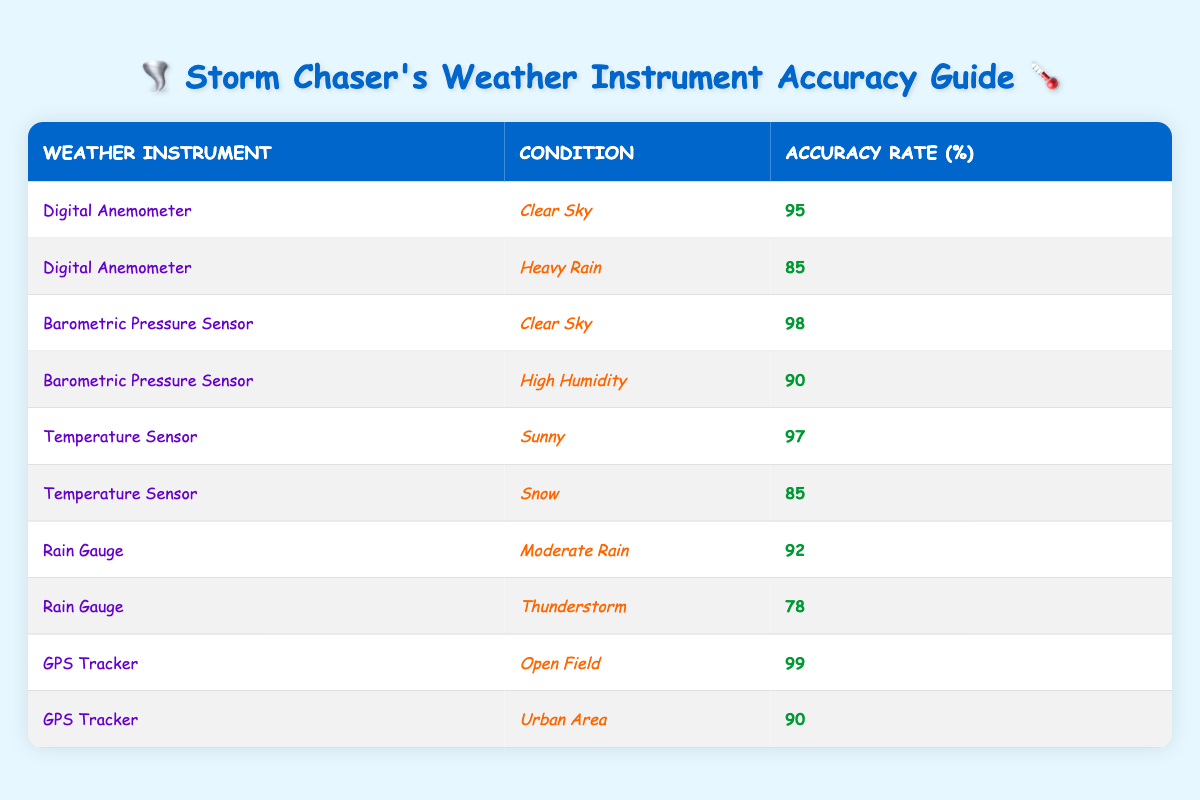What is the accuracy rate of the Digital Anemometer in Clear Sky conditions? The table lists the accuracy rate for the Digital Anemometer under Clear Sky conditions as 95 percent.
Answer: 95 Which weather instrument has the highest accuracy rate in any condition? Upon examining the data, the GPS Tracker has the highest accuracy rate of 99 percent in Open Field conditions.
Answer: 99 Is the accuracy rate of the Rain Gauge higher in Moderate Rain or Thunderstorm conditions? Looking at the table, the Rain Gauge shows an accuracy rate of 92 percent in Moderate Rain and 78 percent in Thunderstorm conditions. Therefore, Moderate Rain has the higher accuracy rate.
Answer: Yes What is the average accuracy rate for the Barometric Pressure Sensor? The accuracy rates for the Barometric Pressure Sensor are 98 percent in Clear Sky and 90 percent in High Humidity. To find the average, we sum these rates: (98 + 90) = 188, and then divide by 2, which gives us 188 / 2 = 94.
Answer: 94 Is there any weather instrument that maintains an accuracy rate of 85 percent in more than one condition? Analyzing the table, the Digital Anemometer shows an accuracy rate of 85 percent in Heavy Rain, and the Temperature Sensor has an accuracy rate of 85 percent in Snow. Hence, both instruments maintain this accuracy rate in different conditions.
Answer: Yes Which instrument has the lowest accuracy rate, and what is that rate? The table indicates that the Rain Gauge has the lowest accuracy rate of 78 percent during Thunderstorm conditions, making it the instrument with the lowest accuracy overall.
Answer: 78 If we combine the accuracy rates of the Digital Anemometer in both clear sky and heavy rain, what is the total? The Digital Anemometer has an accuracy rate of 95 percent in Clear Sky conditions and 85 percent in Heavy Rain. Adding these rates gives us: 95 + 85 = 180.
Answer: 180 In what condition does the Temperature Sensor experience a lower accuracy rate? The Temperature Sensor has an accuracy rate of 97 percent in Sunny conditions and 85 percent in Snow conditions. Hence, it experiences the lower accuracy rate in Snow.
Answer: Snow What is the accuracy rate of the GPS Tracker in Urban Areas compared to that in Open Fields? The GPS Tracker has an accuracy rate of 90 percent in Urban Areas and 99 percent in Open Fields. Thus, it is more accurate in Open Fields than in Urban Areas.
Answer: 90 in Urban Areas, 99 in Open Fields 